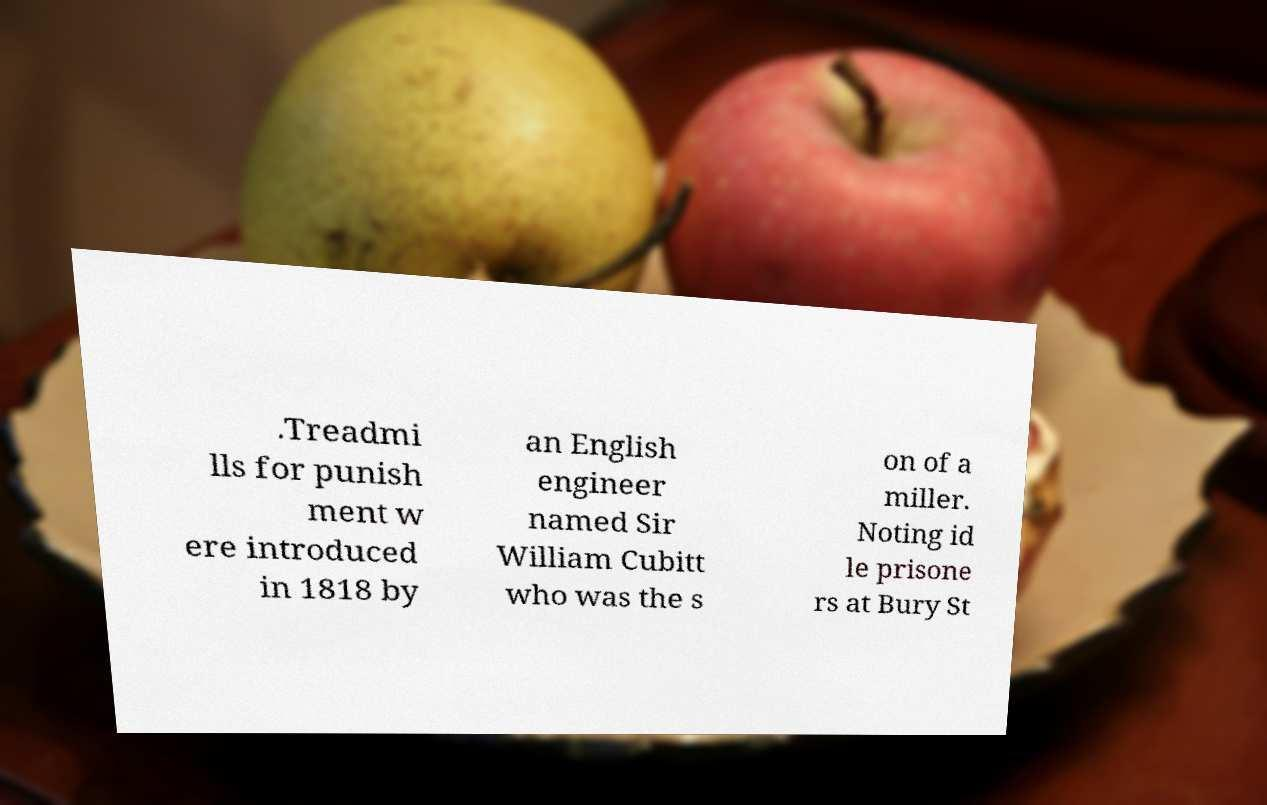For documentation purposes, I need the text within this image transcribed. Could you provide that? .Treadmi lls for punish ment w ere introduced in 1818 by an English engineer named Sir William Cubitt who was the s on of a miller. Noting id le prisone rs at Bury St 